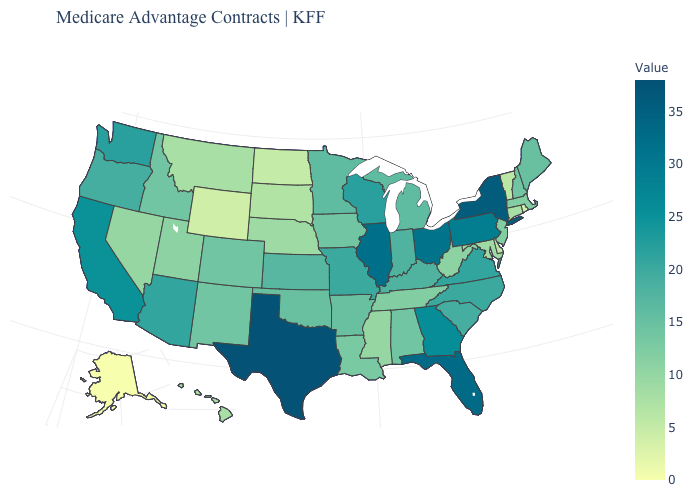Is the legend a continuous bar?
Concise answer only. Yes. Does the map have missing data?
Be succinct. No. Which states hav the highest value in the MidWest?
Concise answer only. Illinois. Does New York have the highest value in the Northeast?
Give a very brief answer. Yes. 